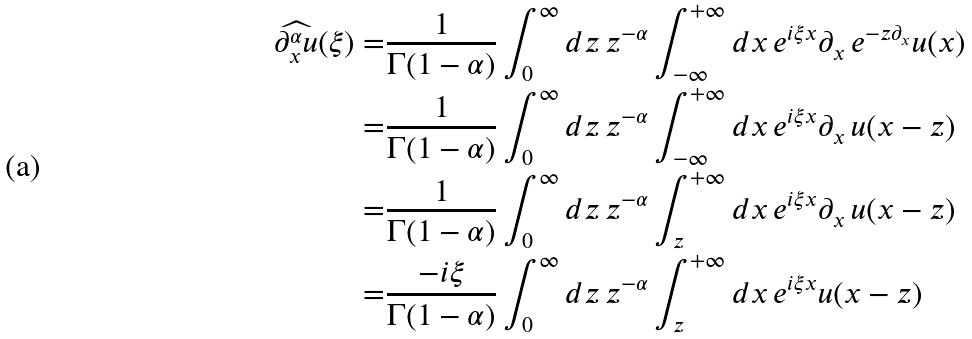Convert formula to latex. <formula><loc_0><loc_0><loc_500><loc_500>\widehat { \partial _ { x } ^ { \alpha } u } ( \xi ) = & \frac { 1 } { \Gamma ( 1 - \alpha ) } \int _ { 0 } ^ { \infty } d z \, z ^ { - \alpha } \int _ { - \infty } ^ { + \infty } d x \, e ^ { i \xi x } \partial _ { x } \, e ^ { - z \partial _ { x } } u ( x ) \\ = & \frac { 1 } { \Gamma ( 1 - \alpha ) } \int _ { 0 } ^ { \infty } d z \, z ^ { - \alpha } \int _ { - \infty } ^ { + \infty } d x \, e ^ { i \xi x } \partial _ { x } \, u ( x - z ) \\ = & \frac { 1 } { \Gamma ( 1 - \alpha ) } \int _ { 0 } ^ { \infty } d z \, z ^ { - \alpha } \int _ { z } ^ { + \infty } d x \, e ^ { i \xi x } \partial _ { x } \, u ( x - z ) \\ = & \frac { - i \xi } { \Gamma ( 1 - \alpha ) } \int _ { 0 } ^ { \infty } d z \, z ^ { - \alpha } \int _ { z } ^ { + \infty } d x \, e ^ { i \xi x } u ( x - z )</formula> 